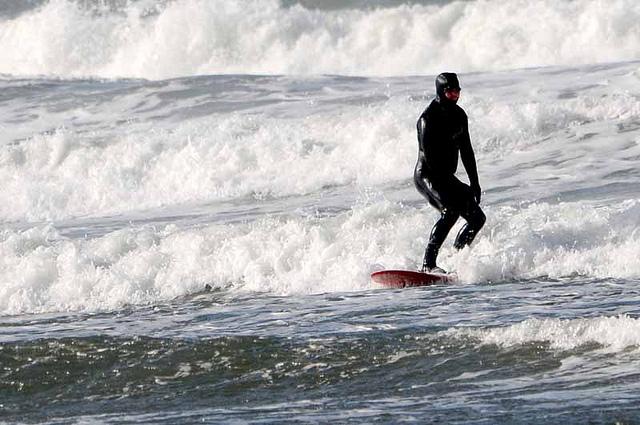Is there water?
Be succinct. Yes. Is that a full wetsuit?
Answer briefly. Yes. What is the man doing?
Give a very brief answer. Surfing. 